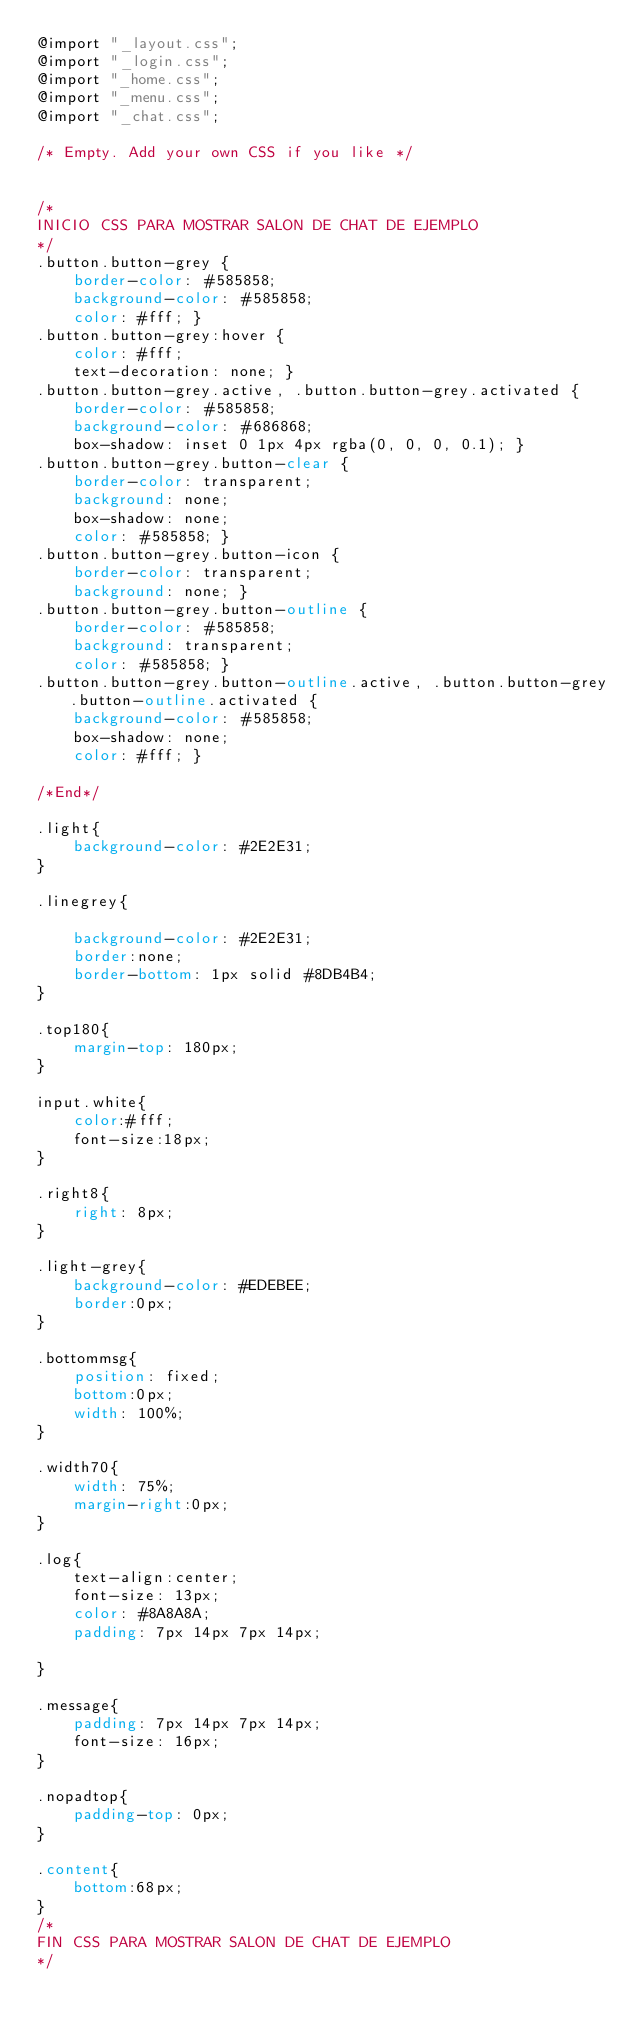<code> <loc_0><loc_0><loc_500><loc_500><_CSS_>@import "_layout.css";
@import "_login.css";
@import "_home.css";
@import "_menu.css";
@import "_chat.css";

/* Empty. Add your own CSS if you like */


/*
INICIO CSS PARA MOSTRAR SALON DE CHAT DE EJEMPLO
*/
.button.button-grey {
    border-color: #585858;
    background-color: #585858;
    color: #fff; }
.button.button-grey:hover {
    color: #fff;
    text-decoration: none; }
.button.button-grey.active, .button.button-grey.activated {
    border-color: #585858;
    background-color: #686868;
    box-shadow: inset 0 1px 4px rgba(0, 0, 0, 0.1); }
.button.button-grey.button-clear {
    border-color: transparent;
    background: none;
    box-shadow: none;
    color: #585858; }
.button.button-grey.button-icon {
    border-color: transparent;
    background: none; }
.button.button-grey.button-outline {
    border-color: #585858;
    background: transparent;
    color: #585858; }
.button.button-grey.button-outline.active, .button.button-grey.button-outline.activated {
    background-color: #585858;
    box-shadow: none;
    color: #fff; }

/*End*/

.light{
    background-color: #2E2E31;
}

.linegrey{

    background-color: #2E2E31;
    border:none;
    border-bottom: 1px solid #8DB4B4;
}

.top180{
    margin-top: 180px;
}

input.white{
    color:#fff;
    font-size:18px;
}

.right8{
    right: 8px;
}

.light-grey{
    background-color: #EDEBEE;
    border:0px;
}

.bottommsg{
    position: fixed;
    bottom:0px;
    width: 100%;
}

.width70{
    width: 75%;
    margin-right:0px;
}

.log{
    text-align:center;
    font-size: 13px;
    color: #8A8A8A;
    padding: 7px 14px 7px 14px;

}

.message{
    padding: 7px 14px 7px 14px;
    font-size: 16px;
}

.nopadtop{
    padding-top: 0px;
}

.content{
    bottom:68px;
}
/*
FIN CSS PARA MOSTRAR SALON DE CHAT DE EJEMPLO
*/
</code> 